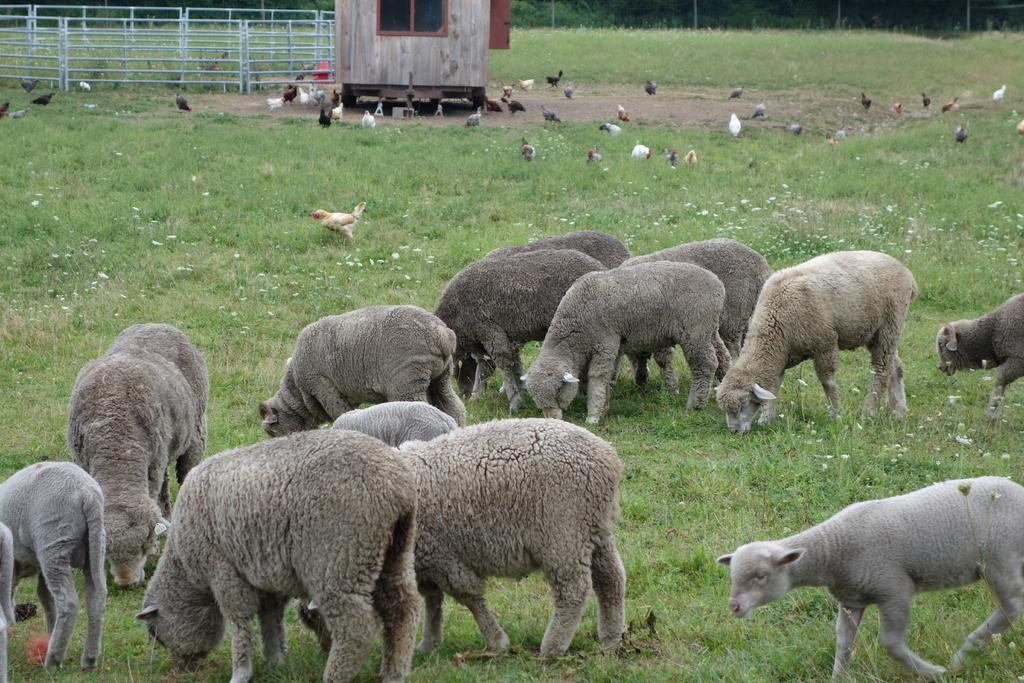How many people are in the image? There is a group of people in the image. What are the people doing in the image? The people are eating grass in the image. What other animals can be seen in the image? There are birds in the image. What type of barrier is present in the image? There is a fence in the image. What other object can be seen in the image? There is a block in the image. How many pizzas are being shared among the people in the image? There is no mention of pizzas in the image; the people are eating grass instead. 